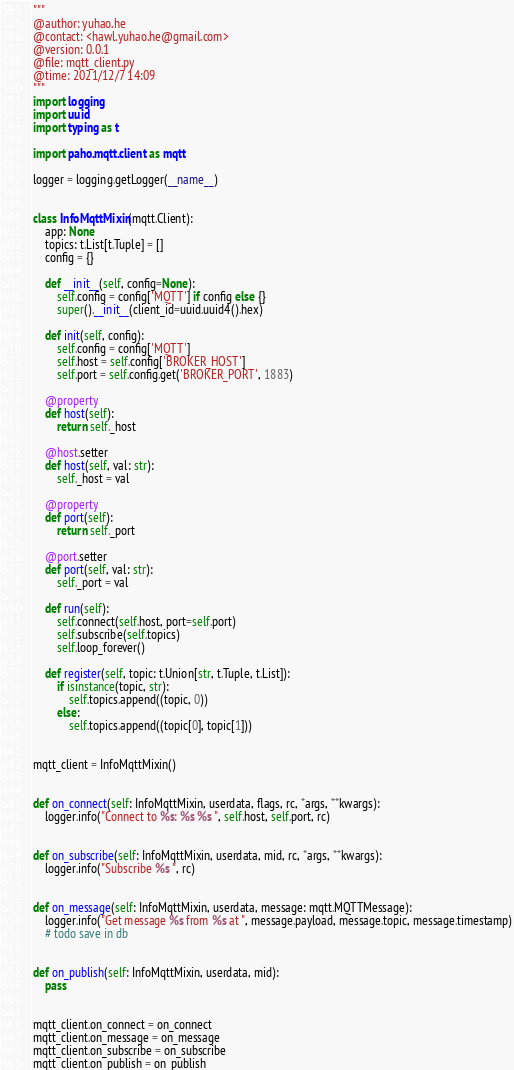<code> <loc_0><loc_0><loc_500><loc_500><_Python_>"""
@author: yuhao.he
@contact: <hawl.yuhao.he@gmail.com>
@version: 0.0.1
@file: mqtt_client.py
@time: 2021/12/7 14:09
"""
import logging
import uuid
import typing as t

import paho.mqtt.client as mqtt

logger = logging.getLogger(__name__)


class InfoMqttMixin(mqtt.Client):
    app: None
    topics: t.List[t.Tuple] = []
    config = {}

    def __init__(self, config=None):
        self.config = config['MQTT'] if config else {}
        super().__init__(client_id=uuid.uuid4().hex)

    def init(self, config):
        self.config = config['MQTT']
        self.host = self.config['BROKER_HOST']
        self.port = self.config.get('BROKER_PORT', 1883)

    @property
    def host(self):
        return self._host

    @host.setter
    def host(self, val: str):
        self._host = val

    @property
    def port(self):
        return self._port

    @port.setter
    def port(self, val: str):
        self._port = val

    def run(self):
        self.connect(self.host, port=self.port)
        self.subscribe(self.topics)
        self.loop_forever()

    def register(self, topic: t.Union[str, t.Tuple, t.List]):
        if isinstance(topic, str):
            self.topics.append((topic, 0))
        else:
            self.topics.append((topic[0], topic[1]))


mqtt_client = InfoMqttMixin()


def on_connect(self: InfoMqttMixin, userdata, flags, rc, *args, **kwargs):
    logger.info("Connect to %s: %s %s ", self.host, self.port, rc)


def on_subscribe(self: InfoMqttMixin, userdata, mid, rc, *args, **kwargs):
    logger.info("Subscribe %s ", rc)


def on_message(self: InfoMqttMixin, userdata, message: mqtt.MQTTMessage):
    logger.info("Get message %s from %s at ", message.payload, message.topic, message.timestamp)
    # todo save in db


def on_publish(self: InfoMqttMixin, userdata, mid):
    pass


mqtt_client.on_connect = on_connect
mqtt_client.on_message = on_message
mqtt_client.on_subscribe = on_subscribe
mqtt_client.on_publish = on_publish

</code> 